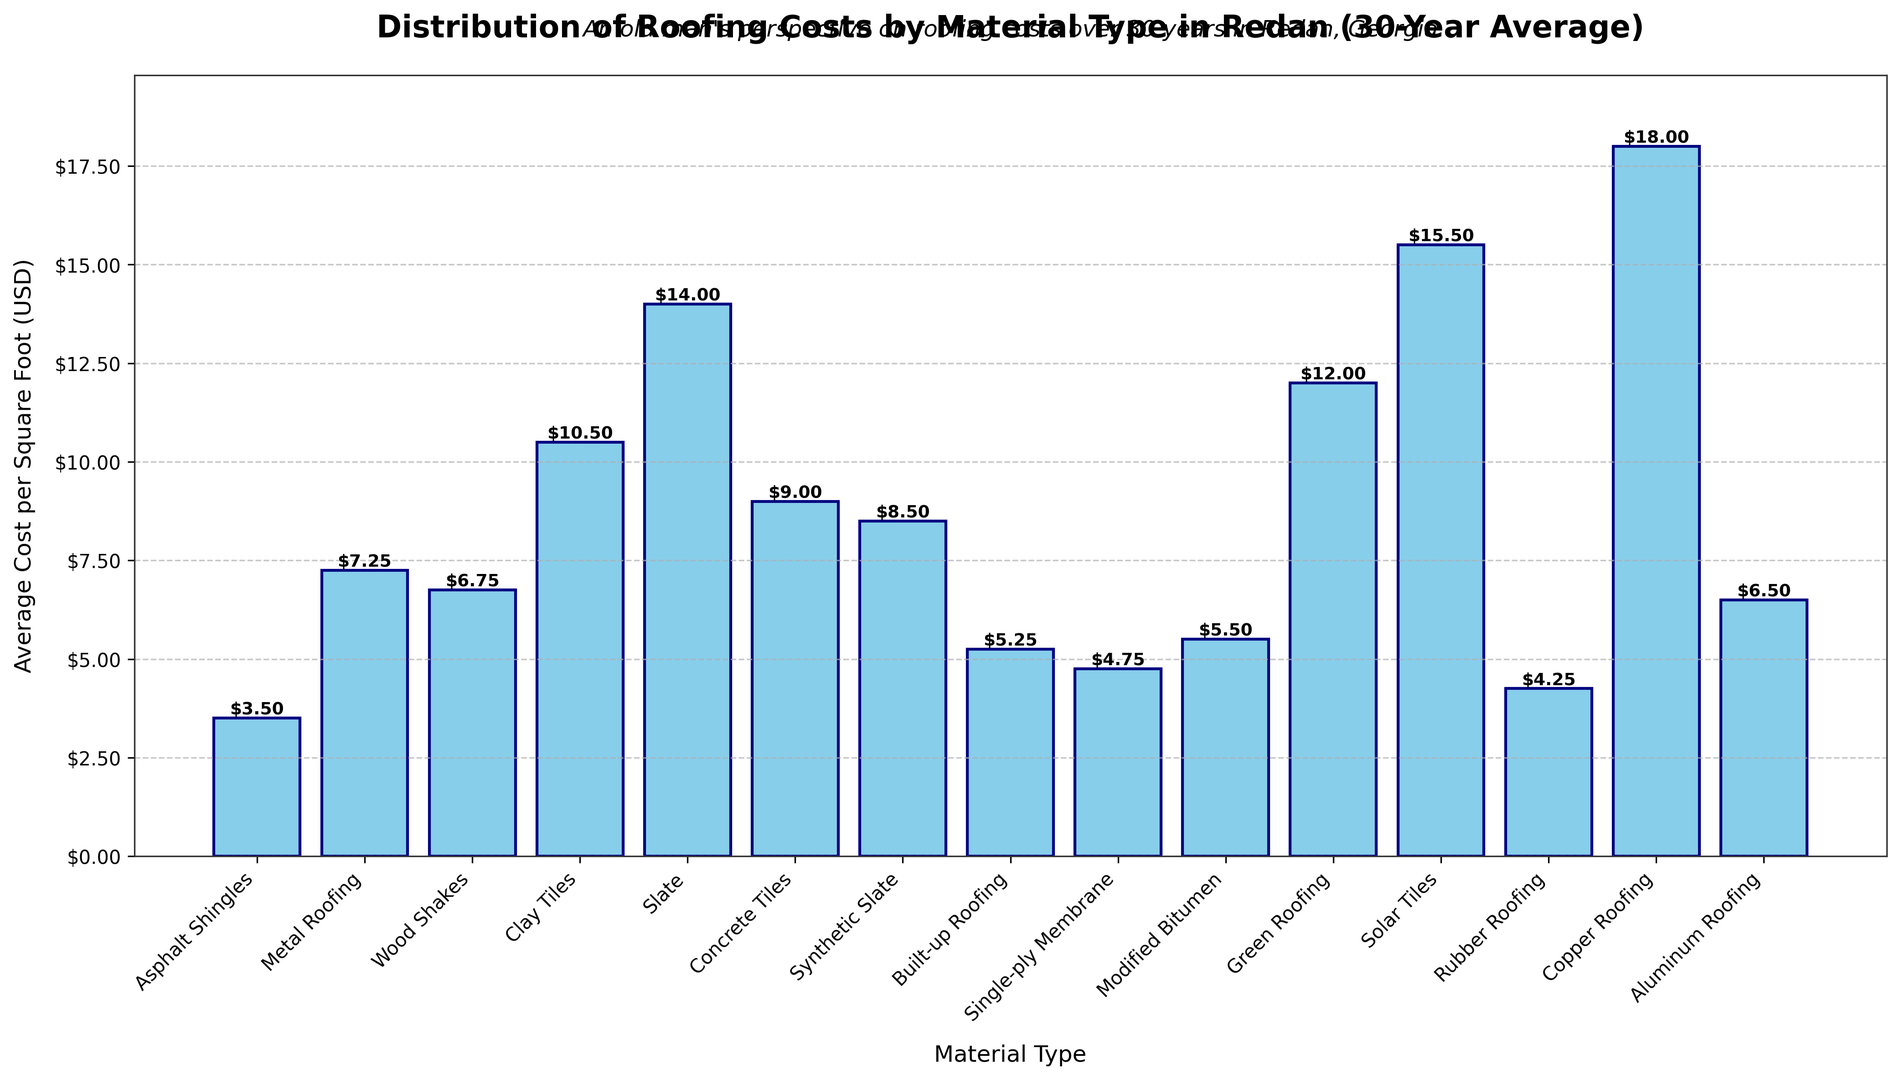What is the most expensive roofing material? The most expensive roofing material can be identified by looking for the bar with the highest value on the y-axis. In the plot, the bar for "Copper Roofing" reaches the highest point at $18.00.
Answer: Copper Roofing What is the cost difference between Asphalt Shingles and Clay Tiles? To find the cost difference, subtract the average cost of Asphalt Shingles from the average cost of Clay Tiles. The cost of Asphalt Shingles is $3.50, and the cost of Clay Tiles is $10.50; hence the difference is $10.50 - $3.50 = $7.00.
Answer: $7.00 Which material is cheaper, Wood Shakes or Aluminum Roofing? To determine which material is cheaper, compare the heights of the bars for Wood Shakes and Aluminum Roofing on the y-axis. Wood Shakes cost $6.75, and Aluminum Roofing costs $6.50, making Aluminum Roofing cheaper.
Answer: Aluminum Roofing What is the average cost of Synthetic Slate and Built-up Roofing? Add the costs of Synthetic Slate and Built-up Roofing, then divide by 2. The cost of Synthetic Slate is $8.50, and the cost of Built-up Roofing is $5.25. So, the average is ($8.50 + $5.25) / 2 = $6.875.
Answer: $6.88 Which roofing material is slightly more expensive, Metal Roofing or Wood Shakes? Compare the heights of the bars for Metal Roofing and Wood Shakes. Metal Roofing costs $7.25, whereas Wood Shakes costs $6.75. Therefore, Metal Roofing is slightly more expensive by $0.50.
Answer: Metal Roofing How many roofing materials have an average cost above $10 per square foot? Identify the bars that reach above the $10 mark on the y-axis. The materials costing above $10 are Clay Tiles ($10.50), Green Roofing ($12.00), Slate ($14.00), Solar Tiles ($15.50), and Copper Roofing ($18.00). Hence, there are 5 materials.
Answer: 5 What is the total cost of Single-ply Membrane and Rubber Roofing combined? Add the costs of Single-ply Membrane and Rubber Roofing. Single-ply Membrane costs $4.75, and Rubber Roofing costs $4.25. So, the combined cost is $4.75 + $4.25 = $9.00.
Answer: $9.00 Which material has a lower cost per square foot, Modified Bitumen or Built-up Roofing? Compare the heights of the bars for Modified Bitumen and Built-up Roofing. Modified Bitumen costs $5.50, whereas Built-up Roofing costs $5.25. So, Built-up Roofing is cheaper.
Answer: Built-up Roofing What is the cost difference between the cheapest and the most expensive roofing materials? The cheapest material is Asphalt Shingles at $3.50, and the most expensive material is Copper Roofing at $18.00. The difference is $18.00 - $3.50 = $14.50.
Answer: $14.50 